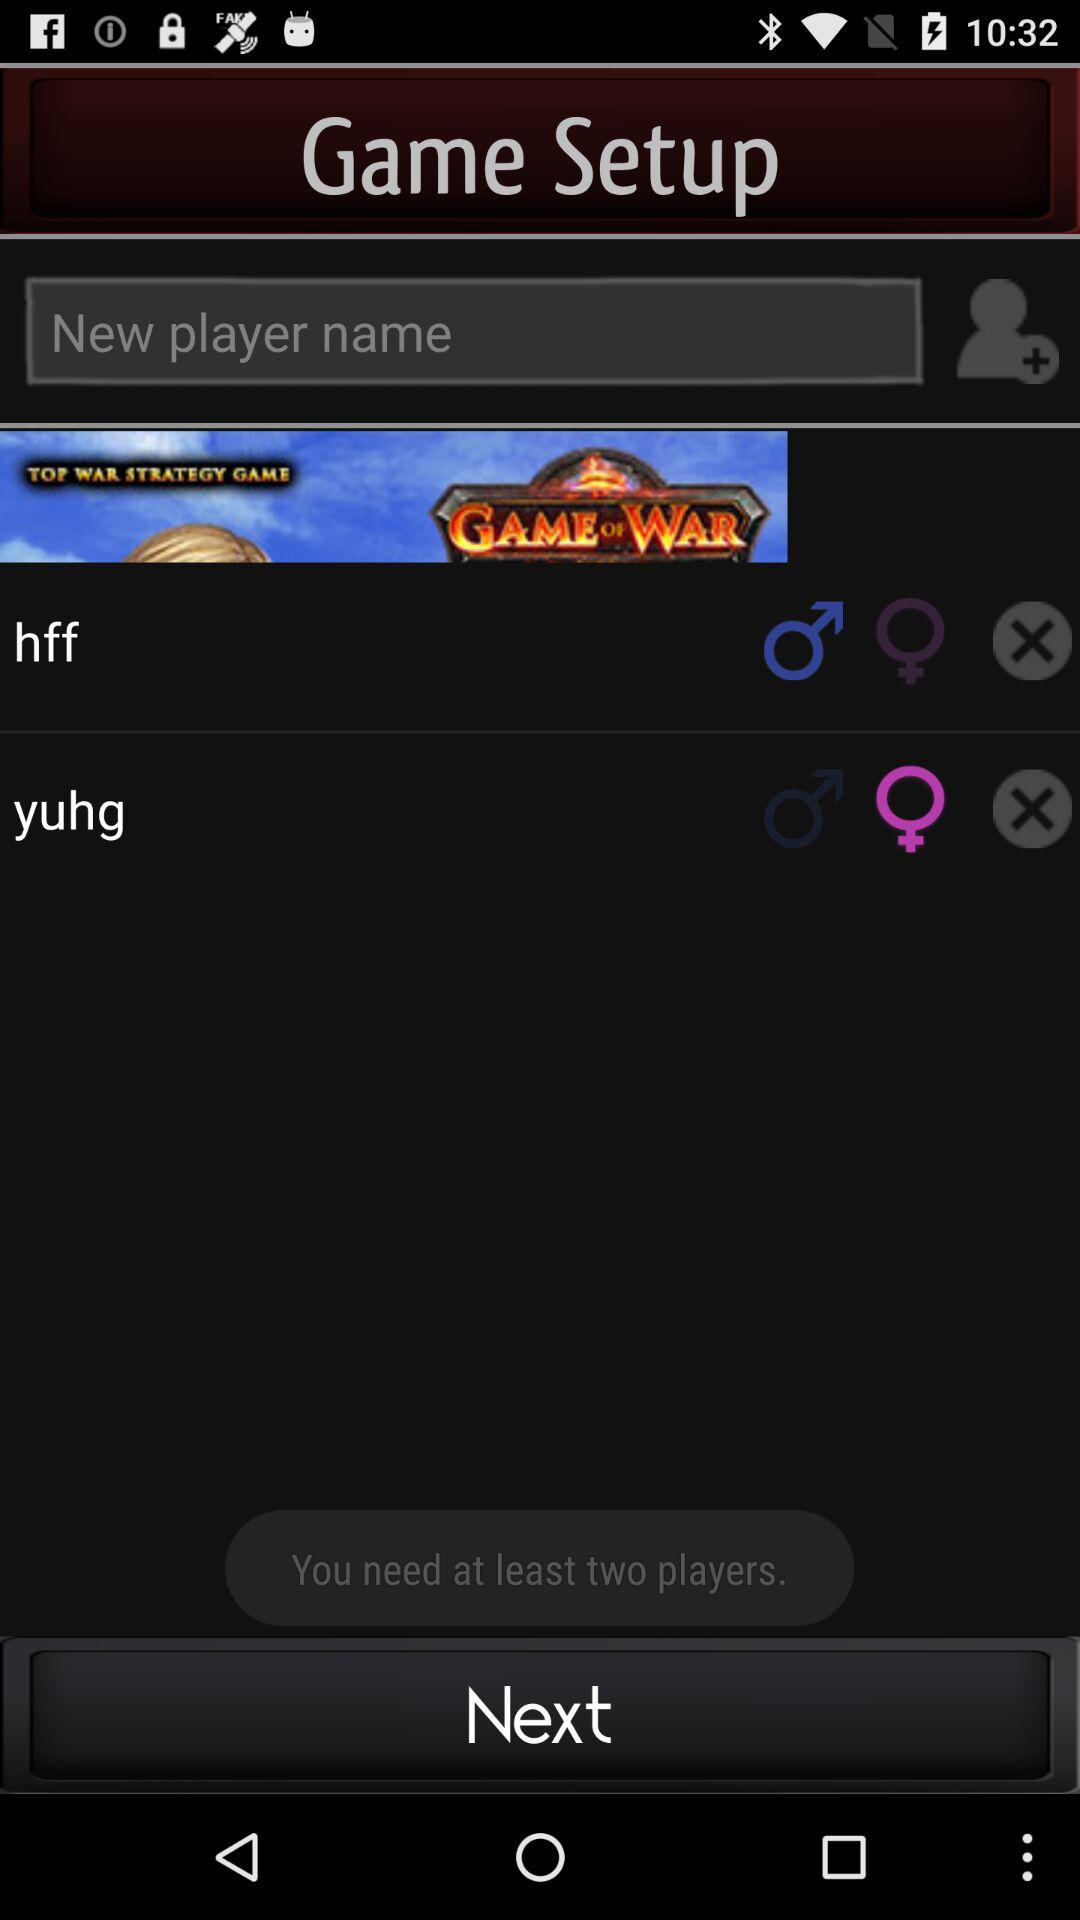How many players are already in the game?
Answer the question using a single word or phrase. 2 